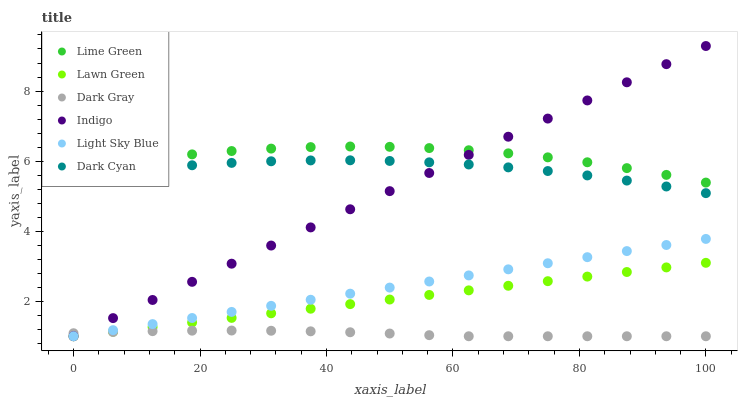Does Dark Gray have the minimum area under the curve?
Answer yes or no. Yes. Does Lime Green have the maximum area under the curve?
Answer yes or no. Yes. Does Indigo have the minimum area under the curve?
Answer yes or no. No. Does Indigo have the maximum area under the curve?
Answer yes or no. No. Is Light Sky Blue the smoothest?
Answer yes or no. Yes. Is Lime Green the roughest?
Answer yes or no. Yes. Is Indigo the smoothest?
Answer yes or no. No. Is Indigo the roughest?
Answer yes or no. No. Does Lawn Green have the lowest value?
Answer yes or no. Yes. Does Dark Cyan have the lowest value?
Answer yes or no. No. Does Indigo have the highest value?
Answer yes or no. Yes. Does Dark Gray have the highest value?
Answer yes or no. No. Is Light Sky Blue less than Lime Green?
Answer yes or no. Yes. Is Lime Green greater than Dark Gray?
Answer yes or no. Yes. Does Indigo intersect Dark Gray?
Answer yes or no. Yes. Is Indigo less than Dark Gray?
Answer yes or no. No. Is Indigo greater than Dark Gray?
Answer yes or no. No. Does Light Sky Blue intersect Lime Green?
Answer yes or no. No. 